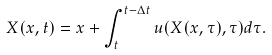<formula> <loc_0><loc_0><loc_500><loc_500>X ( x , t ) = x + \int _ { t } ^ { t - \Delta t } { u ( X ( x , \tau ) , \tau ) d \tau } .</formula> 